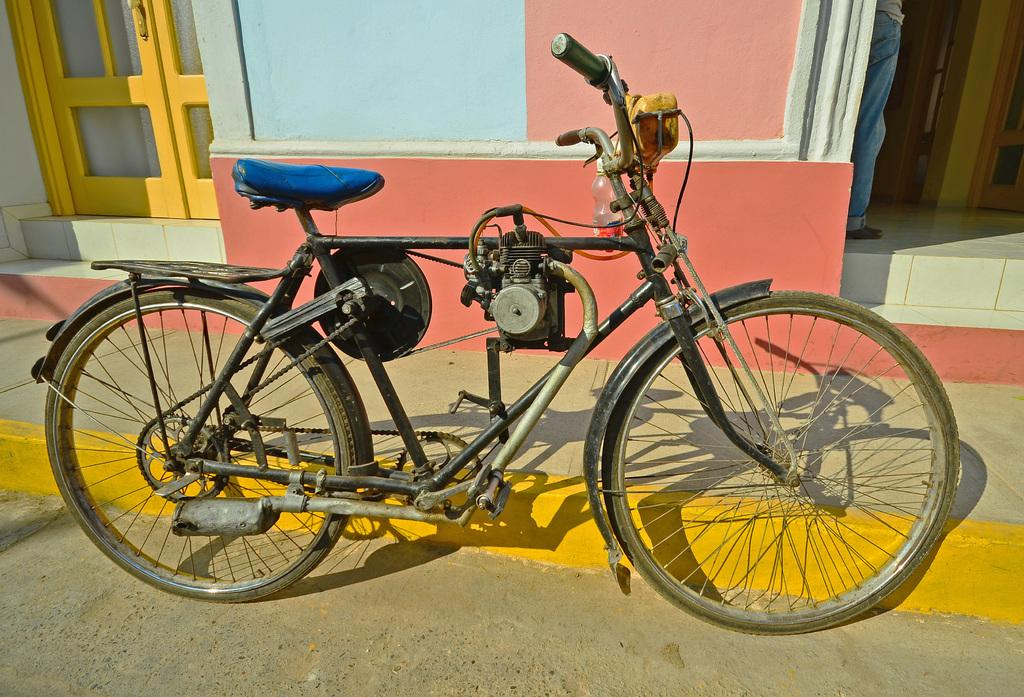What is the main object in the image? There is a bicycle in the image. Who is present in the image? There is a person standing in the image. What is the person wearing? The person is wearing clothes and shoes. What type of surface is visible in the image? There is a floor visible in the image. What architectural features can be seen in the image? There is a wall and a door visible in the image. What type of frog can be seen jumping on the bicycle in the image? There is no frog present in the image, and therefore no such activity can be observed. 